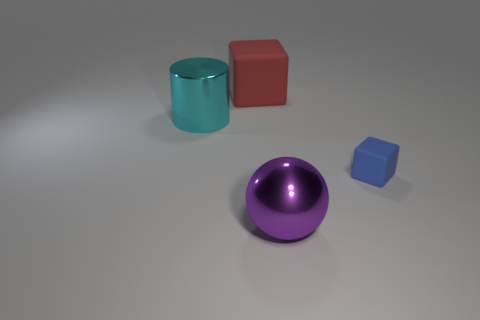There is a block to the right of the metallic object that is in front of the rubber thing in front of the large red cube; what is its material?
Your answer should be compact. Rubber. What is the big block made of?
Provide a succinct answer. Rubber. There is a thing that is both right of the cyan shiny thing and to the left of the large purple object; what material is it made of?
Your answer should be very brief. Rubber. Is the big purple ball that is in front of the cyan metal thing made of the same material as the cube on the left side of the blue matte cube?
Keep it short and to the point. No. What number of balls are either cyan shiny things or purple objects?
Provide a short and direct response. 1. How many other things are made of the same material as the red thing?
Keep it short and to the point. 1. There is a big object that is behind the metallic cylinder; what is its shape?
Provide a succinct answer. Cube. There is a thing that is in front of the blue object on the right side of the large cyan metallic thing; what is its material?
Offer a terse response. Metal. Is the number of rubber cubes behind the large cyan metallic thing greater than the number of big blue rubber things?
Keep it short and to the point. Yes. How many other objects are the same color as the small cube?
Provide a succinct answer. 0. 